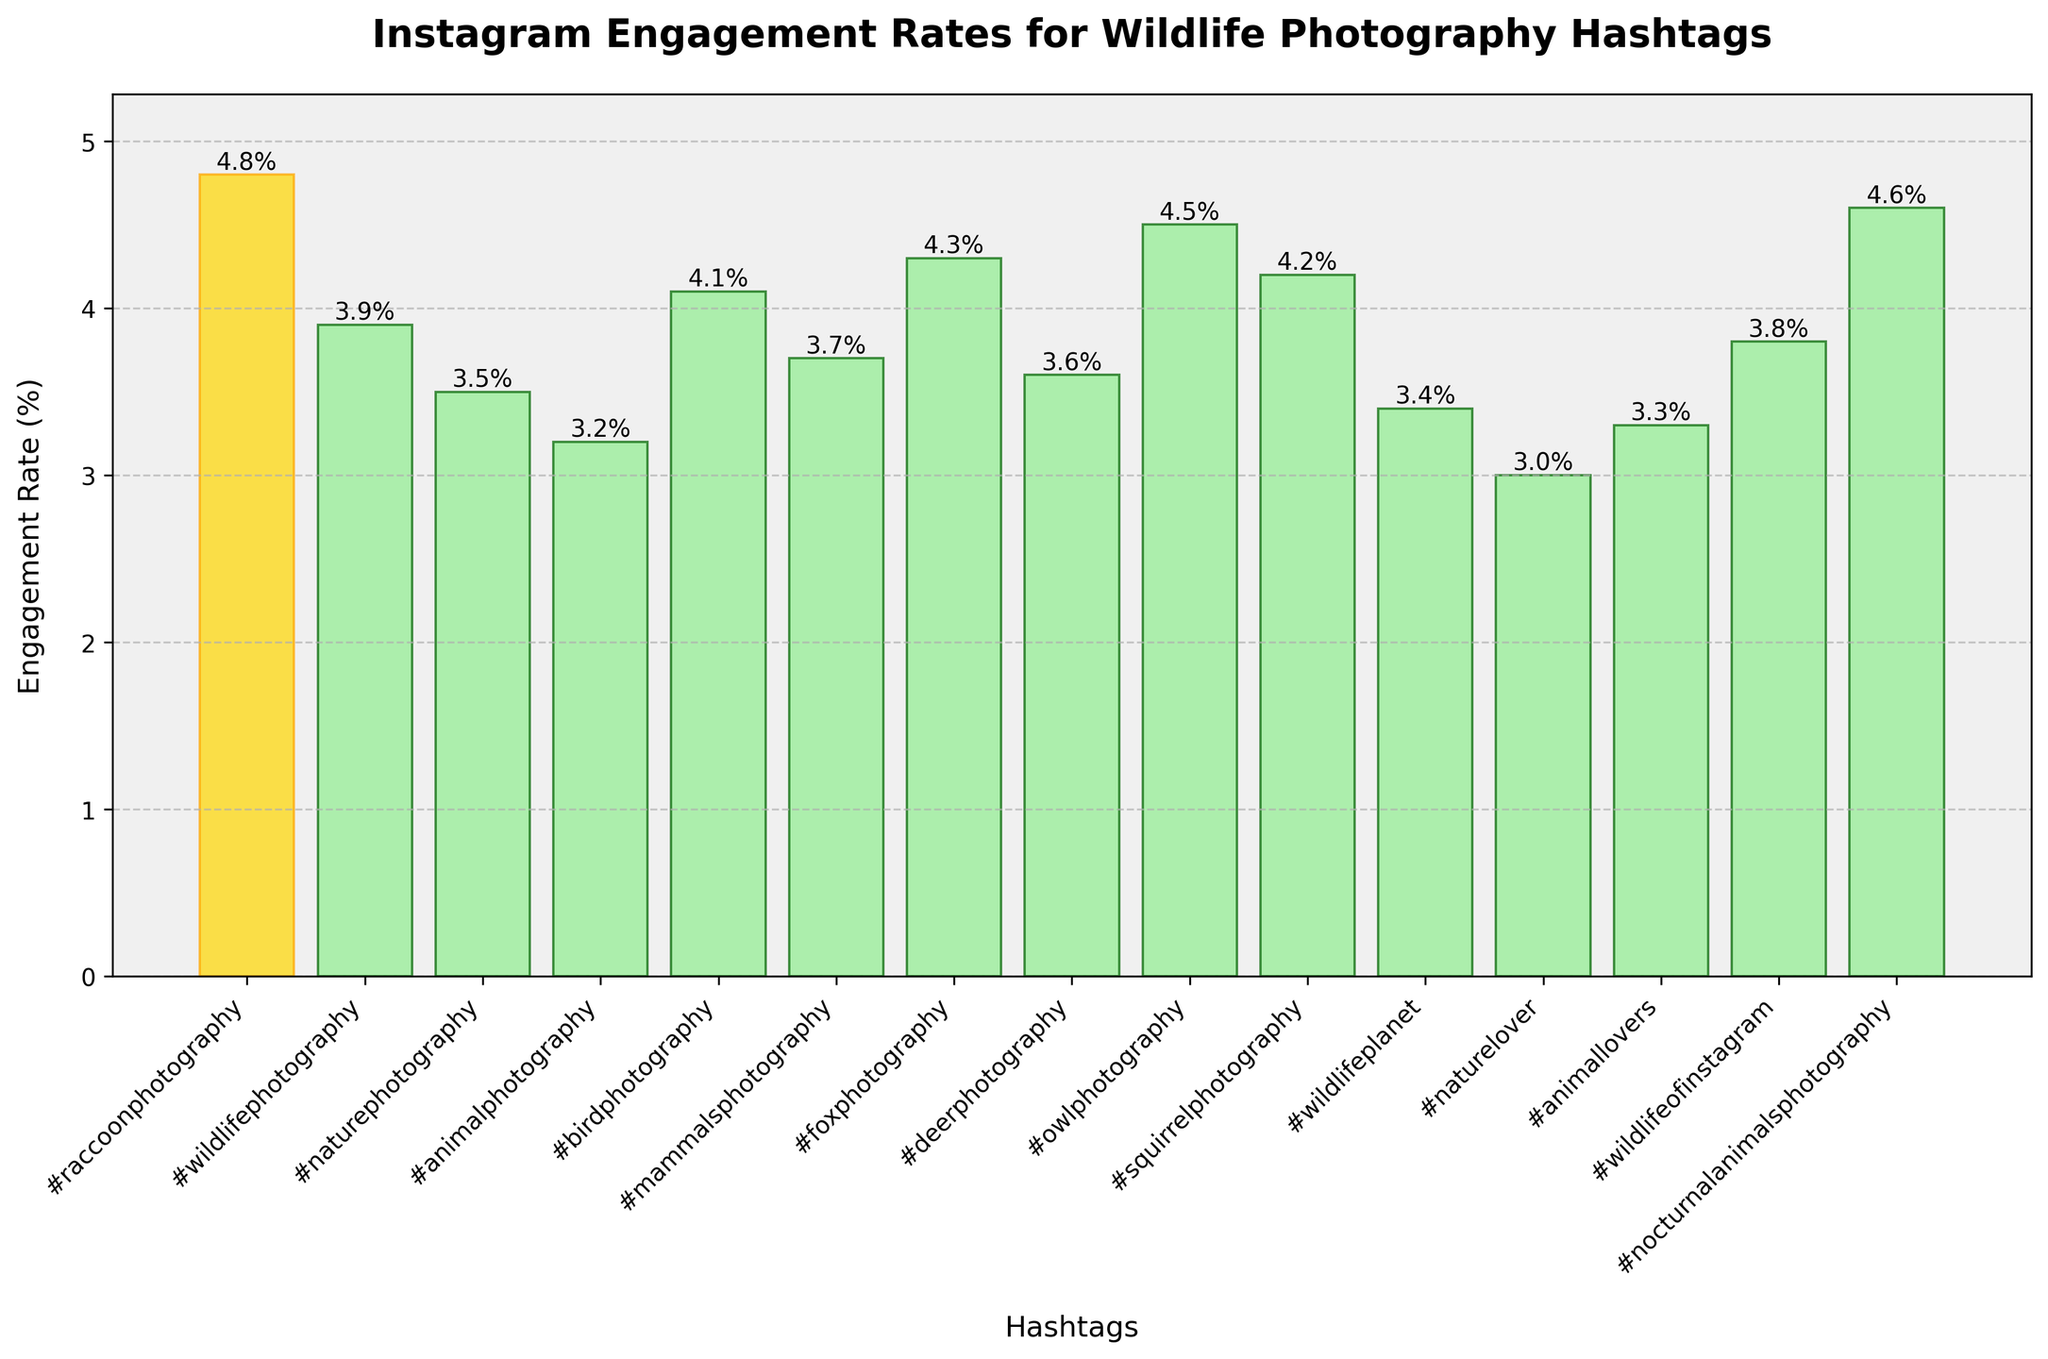Which hashtag has the highest engagement rate? To identify the hashtag with the highest engagement rate, we can visually inspect the figure for the tallest bar.
Answer: #raccoonphotography What is the engagement rate for #naturephotography? Look at the height of the bar corresponding to the hashtag #naturephotography in the figure and find the value at the top of the bar.
Answer: 3.5% How much higher is the engagement rate for #raccoonphotography compared to #wildlifephotography? First, find the engagement rates for both hashtags from the figure, which are 4.8% for #raccoonphotography and 3.9% for #wildlifephotography. Subtract the engagement rate of #wildlifephotography from that of #raccoonphotography.
Answer: 4.8% - 3.9% = 0.9% Which hashtags have an engagement rate greater than 4% but less than 4.5%? Check the bars with heights between 4% and 4.5% and identify the corresponding hashtags.
Answer: #birdphotography, #foxphotography, #squirrelphotography What is the median engagement rate of the hashtags? List all engagement rates, order them from smallest to largest, and find the middle value or the average of the two middle values if there's an even number. Engagement rates: 3.0%, 3.2%, 3.3%, 3.4%, 3.5%, 3.6%, 3.7%, 3.8%, 3.9%, 4.1%, 4.2%, 4.3%, 4.5%, 4.6%, 4.8%. The middle value is the 8th one: 3.8%.
Answer: 3.8% What is the range of engagement rates shown in the figure? Identify the smallest and largest engagement rates from the figure and subtract the smallest from the largest.
Answer: 4.8% - 3.0% = 1.8% Which hashtag has a bar highlighted in gold? Look for the bar that is visually different, specifically highlighted in gold color.
Answer: #raccoonphotography What percentage of the listed hashtags have engagement rates below 3.5%? Count the number of hashtags with engagement rates below 3.5%, divide by the total number of hashtags, and multiply by 100%. There are 5 hashtags out of 15 with less than 3.5%.
Answer: (5/15) * 100% = 33.3% 